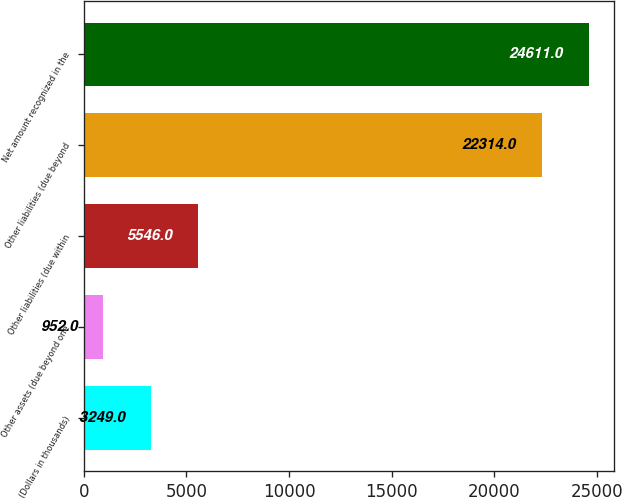Convert chart. <chart><loc_0><loc_0><loc_500><loc_500><bar_chart><fcel>(Dollars in thousands)<fcel>Other assets (due beyond one<fcel>Other liabilities (due within<fcel>Other liabilities (due beyond<fcel>Net amount recognized in the<nl><fcel>3249<fcel>952<fcel>5546<fcel>22314<fcel>24611<nl></chart> 